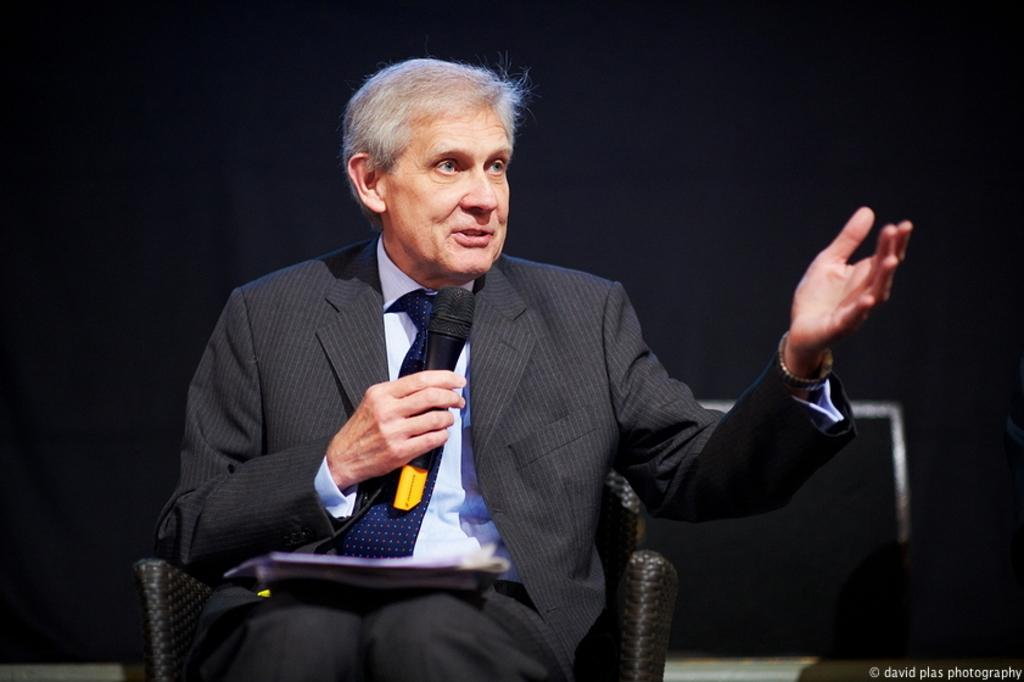What is the man in the image doing? The man is sitting in a chair and holding a mic. What might the man be doing with the mic? The man is likely speaking into the mic, as he is holding it. What direction is the man looking in the image? The man is looking to the side. What action is the man performing with his hand? The man is raising his hand. What type of business is being discussed in the image? There is no indication of a business discussion in the image; the man is holding a mic and raising his hand. What type of feast is being prepared in the image? There is no feast or preparation for a feast visible in the image; the man is sitting in a chair, holding a mic, and raising his hand. 